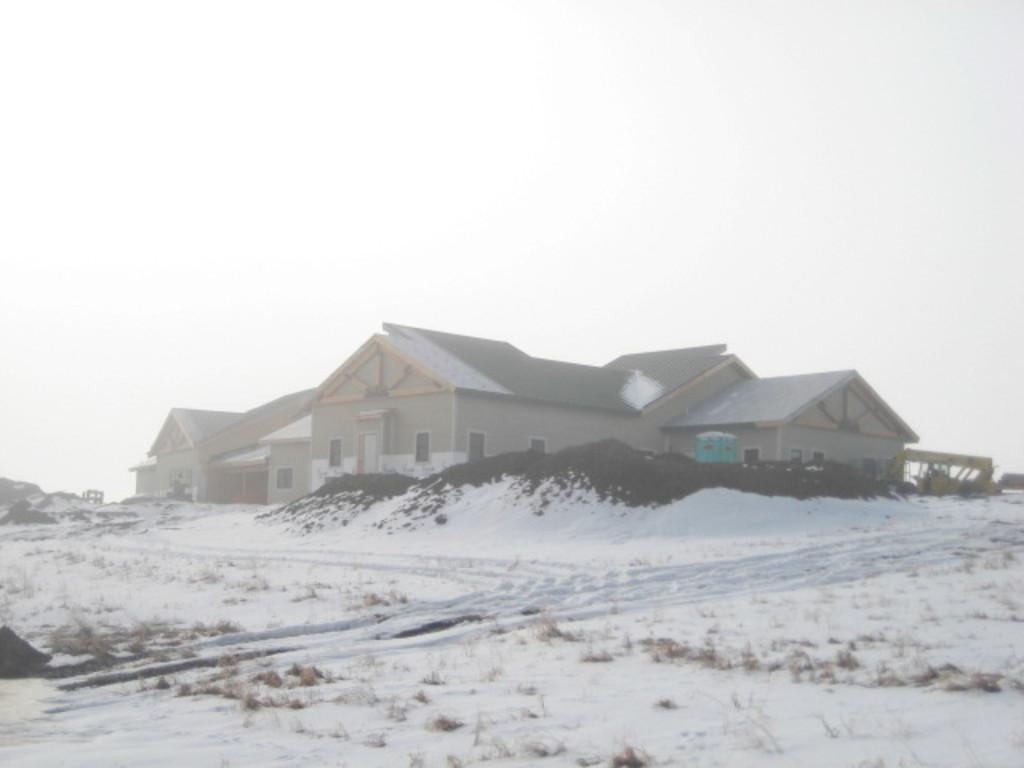Describe this image in one or two sentences. In the picture I can see houses and the snow. In the background I can see the sky. 